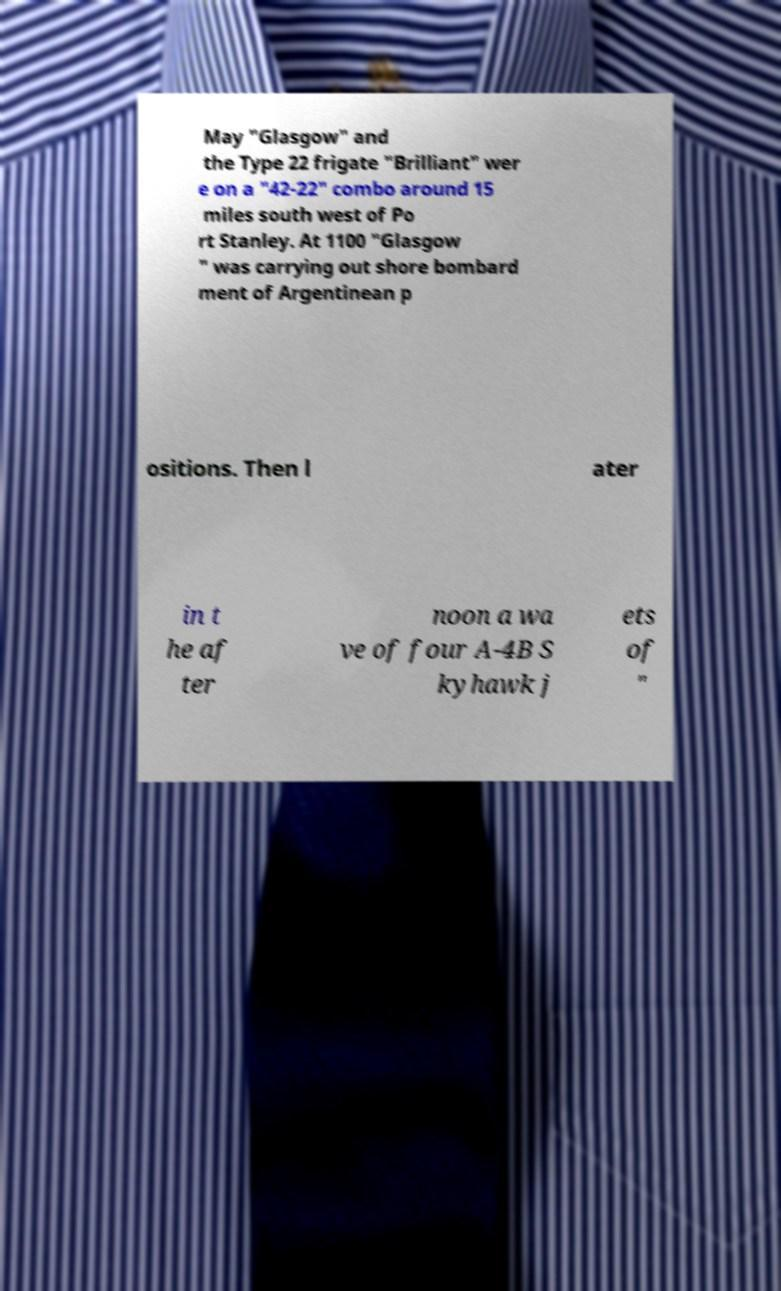Can you accurately transcribe the text from the provided image for me? May "Glasgow" and the Type 22 frigate "Brilliant" wer e on a "42-22" combo around 15 miles south west of Po rt Stanley. At 1100 "Glasgow " was carrying out shore bombard ment of Argentinean p ositions. Then l ater in t he af ter noon a wa ve of four A-4B S kyhawk j ets of " 